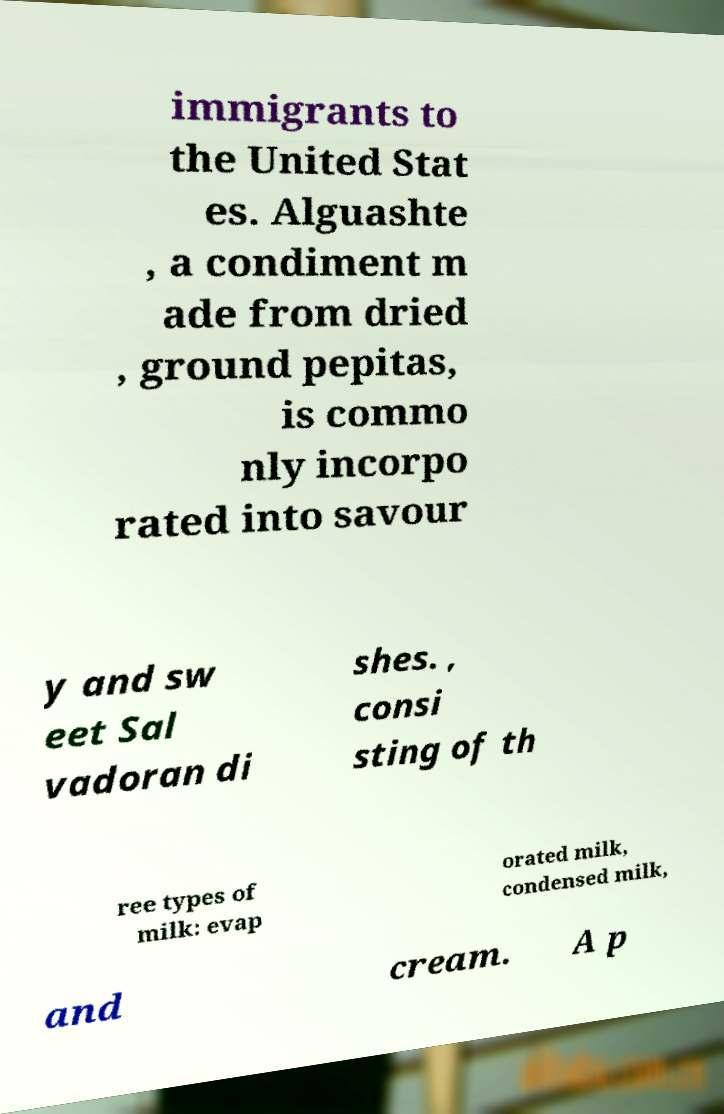There's text embedded in this image that I need extracted. Can you transcribe it verbatim? immigrants to the United Stat es. Alguashte , a condiment m ade from dried , ground pepitas, is commo nly incorpo rated into savour y and sw eet Sal vadoran di shes. , consi sting of th ree types of milk: evap orated milk, condensed milk, and cream. A p 